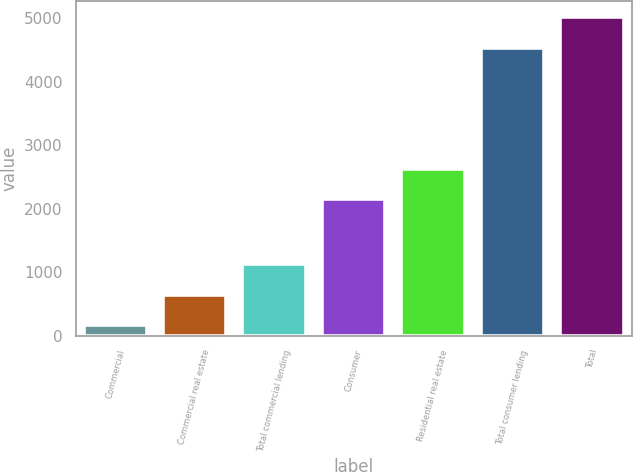Convert chart to OTSL. <chart><loc_0><loc_0><loc_500><loc_500><bar_chart><fcel>Commercial<fcel>Commercial real estate<fcel>Total commercial lending<fcel>Consumer<fcel>Residential real estate<fcel>Total consumer lending<fcel>Total<nl><fcel>159<fcel>643.8<fcel>1128.6<fcel>2145<fcel>2629.8<fcel>4541<fcel>5025.8<nl></chart> 